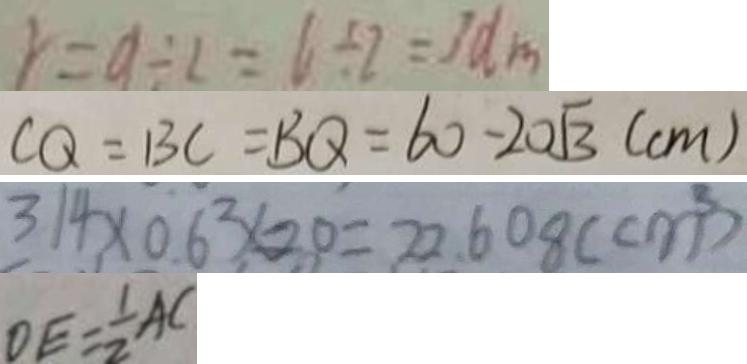Convert formula to latex. <formula><loc_0><loc_0><loc_500><loc_500>r = 9 \div 2 = 6 \div 2 = 3 d m 
 C Q = B C = B Q = 6 0 - 2 0 \sqrt { 3 } ( c m ) 
 3 1 4 \times 0 . 6 ^ { 2 } \times 2 0 = 2 2 . 6 0 8 ( c m ^ { 3 } ) 
 D E = \frac { 1 } { 2 } A C</formula> 